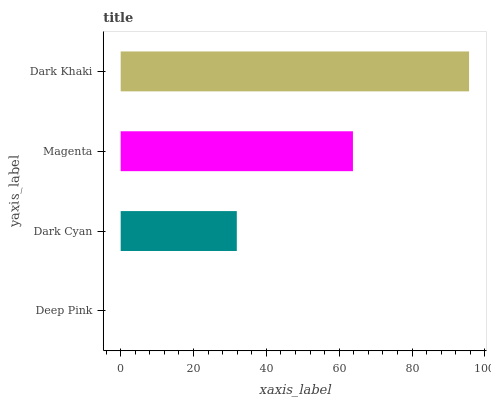Is Deep Pink the minimum?
Answer yes or no. Yes. Is Dark Khaki the maximum?
Answer yes or no. Yes. Is Dark Cyan the minimum?
Answer yes or no. No. Is Dark Cyan the maximum?
Answer yes or no. No. Is Dark Cyan greater than Deep Pink?
Answer yes or no. Yes. Is Deep Pink less than Dark Cyan?
Answer yes or no. Yes. Is Deep Pink greater than Dark Cyan?
Answer yes or no. No. Is Dark Cyan less than Deep Pink?
Answer yes or no. No. Is Magenta the high median?
Answer yes or no. Yes. Is Dark Cyan the low median?
Answer yes or no. Yes. Is Dark Khaki the high median?
Answer yes or no. No. Is Dark Khaki the low median?
Answer yes or no. No. 